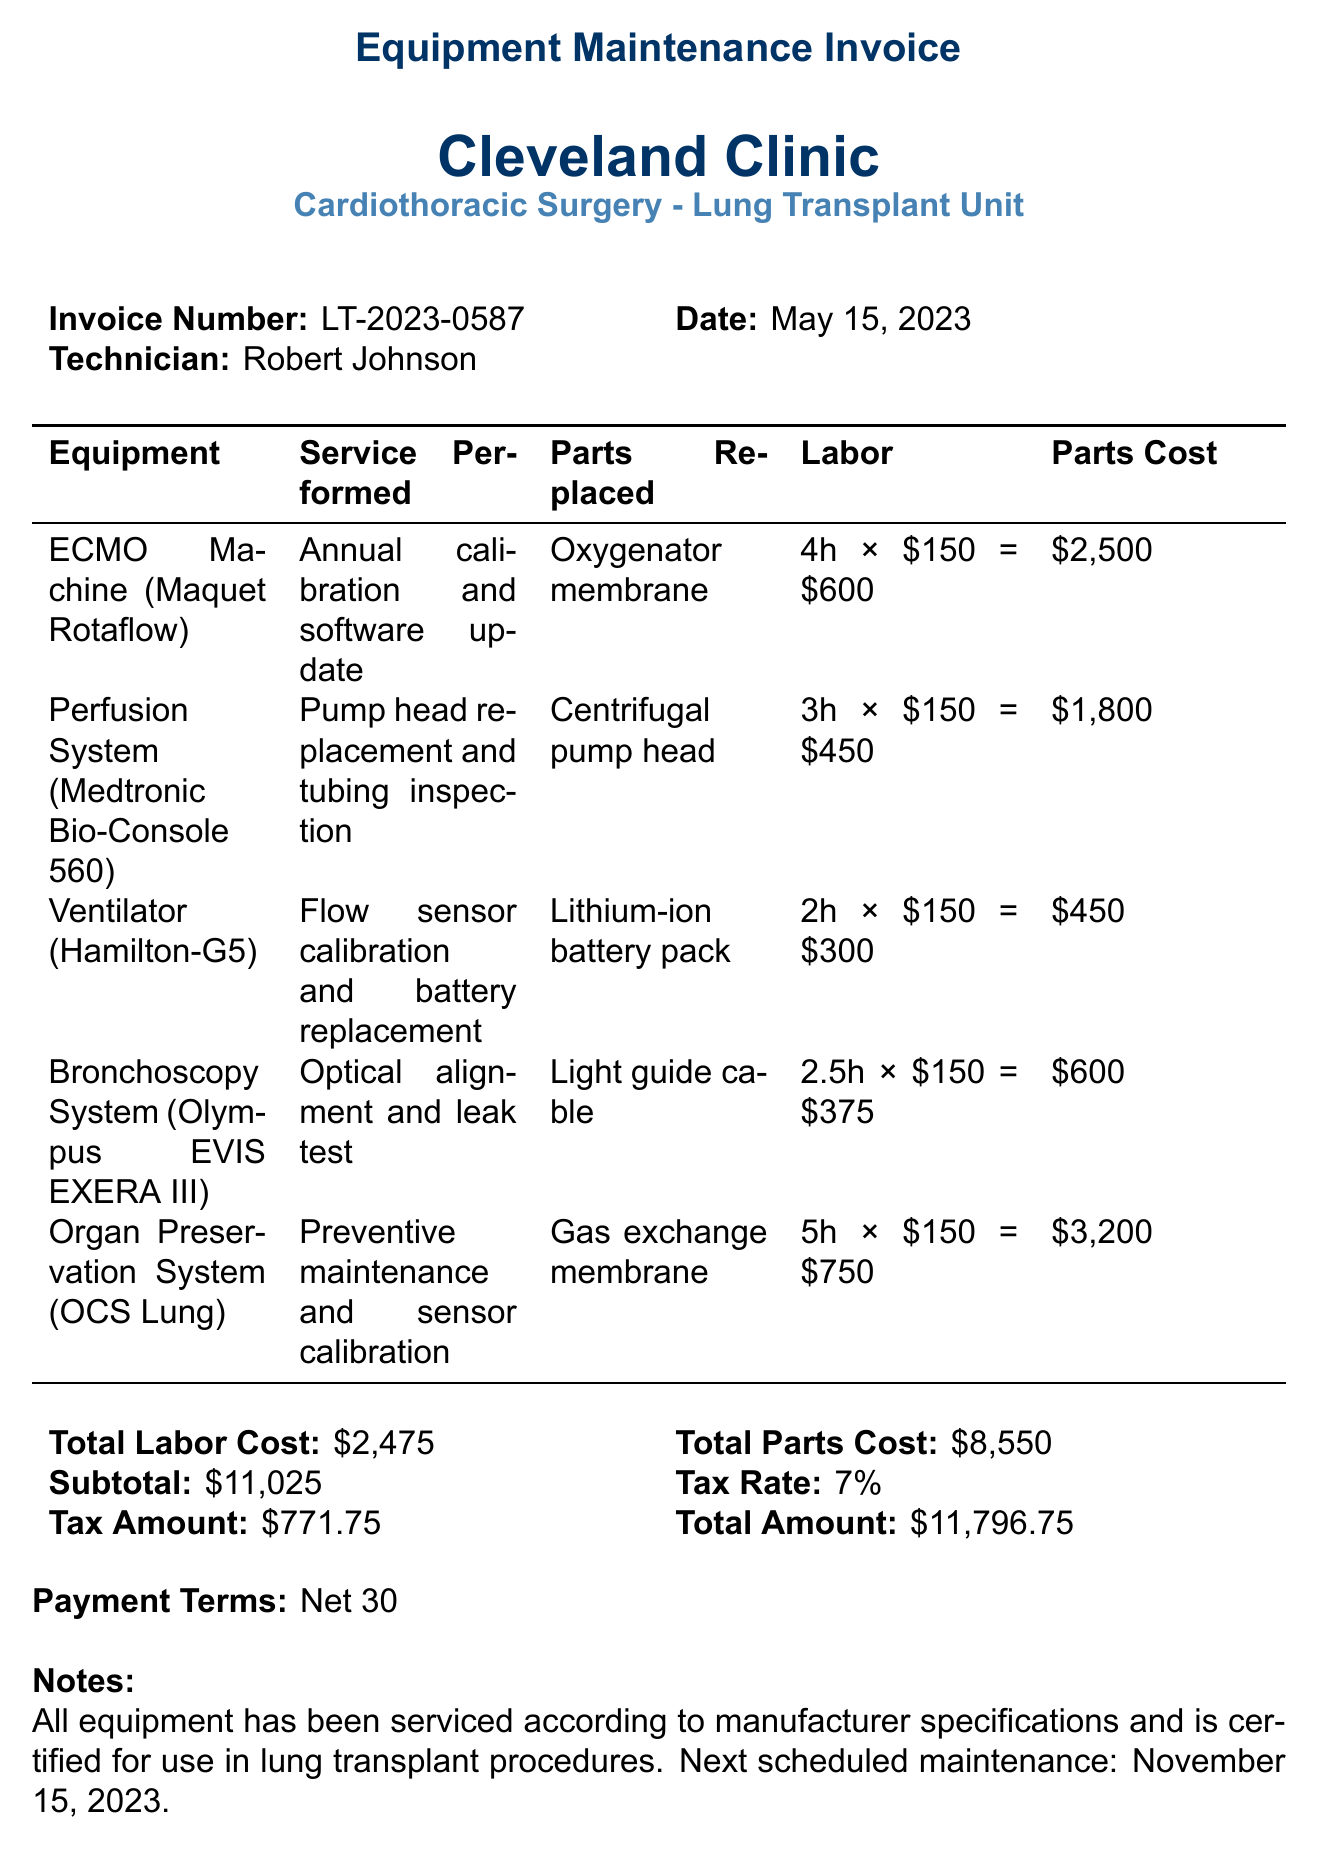What is the invoice number? The invoice number is listed at the top of the document under "Invoice Number."
Answer: LT-2023-0587 Who performed the maintenance? The technician's name is provided in the document, listed as "Technician."
Answer: Robert Johnson What is the total labor cost? The total labor cost is calculated and mentioned in the totals section of the document.
Answer: $2,475 What equipment had the gas exchange membrane replaced? The parts replaced are listed under each equipment item, identifying which parts were serviced.
Answer: Organ Preservation System (OCS Lung) What is the tax amount? The tax amount is given in the totals section, showing the calculation of tax applied to the subtotal.
Answer: $771.75 Which system had a flow sensor calibration? Each piece of equipment has a description of the services performed listed next to it.
Answer: Ventilator (Hamilton-G5) How many hours were spent servicing the Perfusion System? The labor hours for each item serviced are specified under the "Labor" column.
Answer: 3 What is the payment term for this invoice? The payment terms are clearly stated towards the end of the document under "Payment Terms."
Answer: Net 30 When is the next scheduled maintenance? The next scheduled maintenance date is provided in the notes section of the document.
Answer: November 15, 2023 